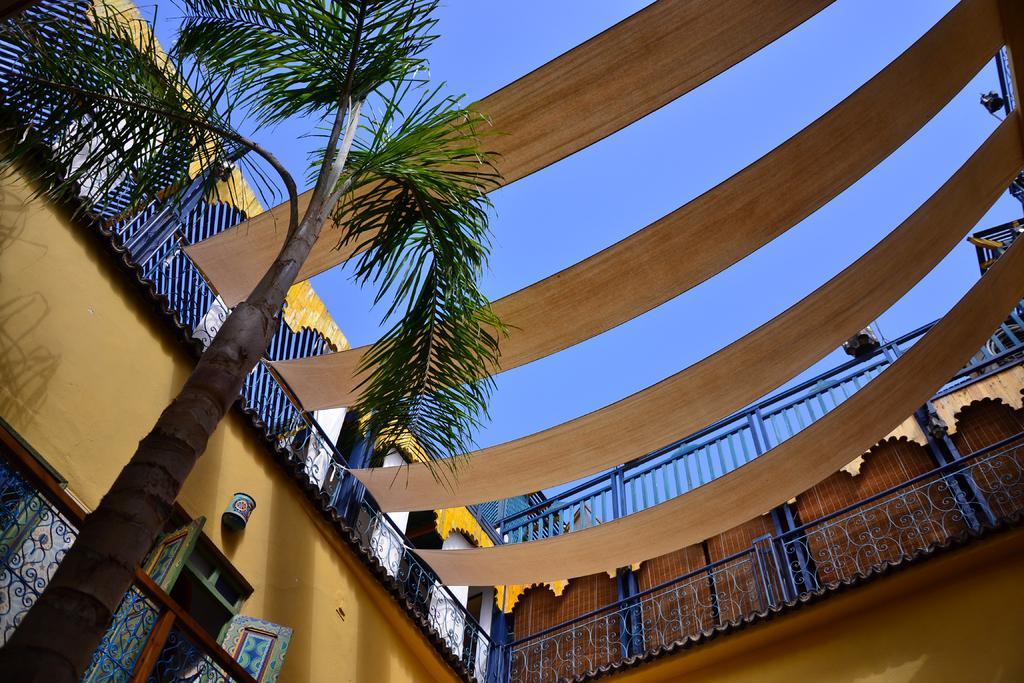In one or two sentences, can you explain what this image depicts? As we can see in the image there are buildings, fence, tree and sky. 